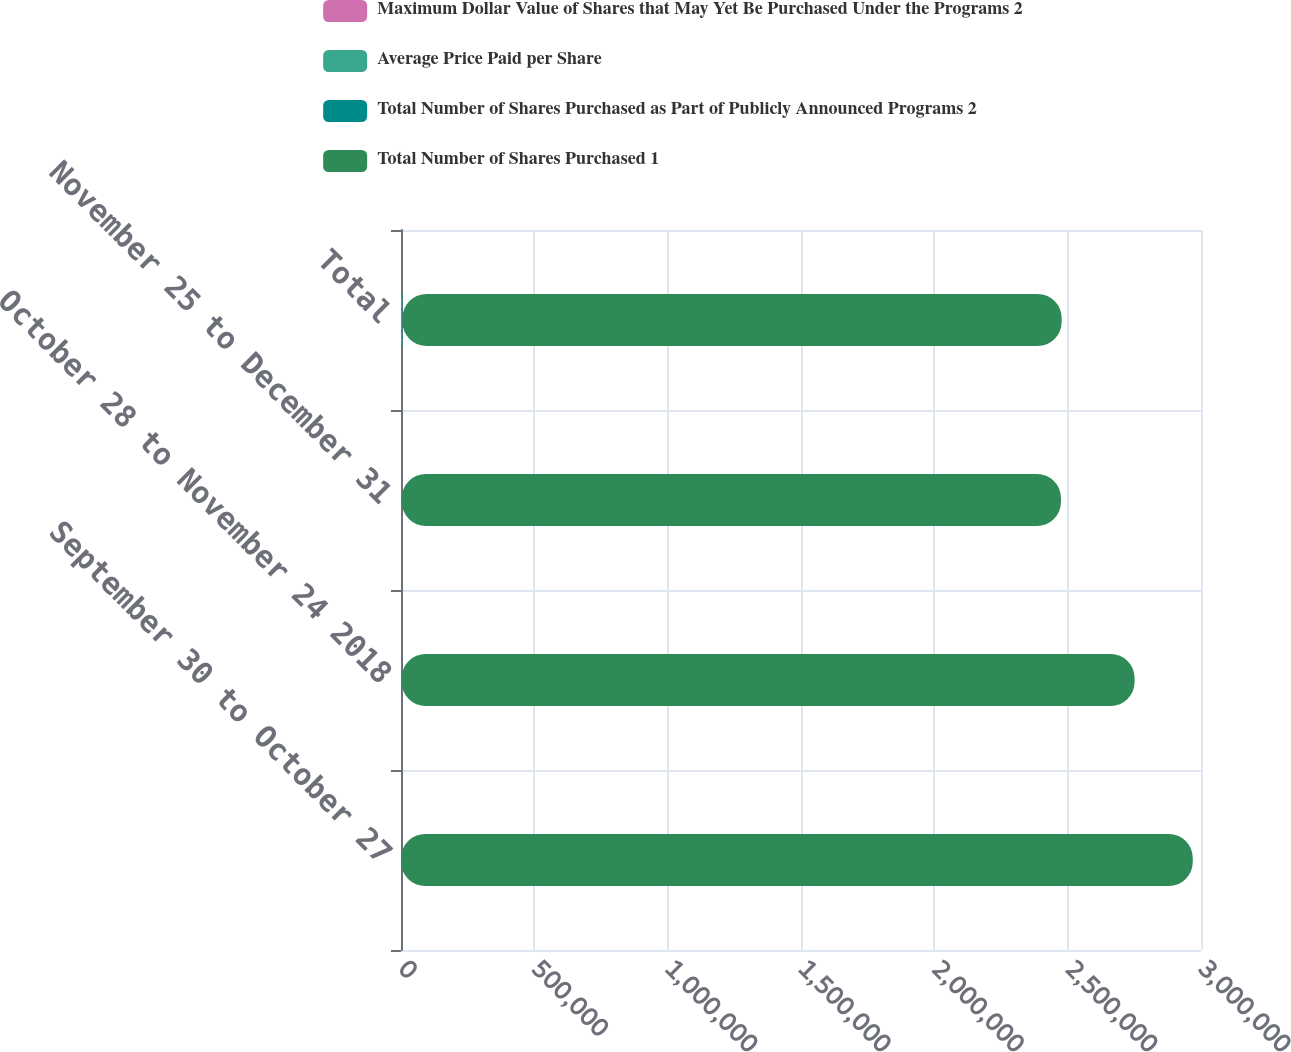Convert chart to OTSL. <chart><loc_0><loc_0><loc_500><loc_500><stacked_bar_chart><ecel><fcel>September 30 to October 27<fcel>October 28 to November 24 2018<fcel>November 25 to December 31<fcel>Total<nl><fcel>Maximum Dollar Value of Shares that May Yet Be Purchased Under the Programs 2<fcel>128<fcel>1126<fcel>1466<fcel>2720<nl><fcel>Average Price Paid per Share<fcel>182.79<fcel>195.56<fcel>189.54<fcel>191.71<nl><fcel>Total Number of Shares Purchased as Part of Publicly Announced Programs 2<fcel>128<fcel>1126<fcel>1460<fcel>2714<nl><fcel>Total Number of Shares Purchased 1<fcel>2.96868e+06<fcel>2.74848e+06<fcel>2.47178e+06<fcel>2.47178e+06<nl></chart> 